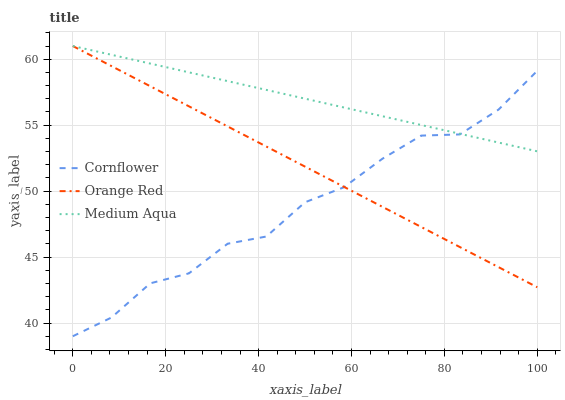Does Cornflower have the minimum area under the curve?
Answer yes or no. Yes. Does Medium Aqua have the maximum area under the curve?
Answer yes or no. Yes. Does Orange Red have the minimum area under the curve?
Answer yes or no. No. Does Orange Red have the maximum area under the curve?
Answer yes or no. No. Is Medium Aqua the smoothest?
Answer yes or no. Yes. Is Cornflower the roughest?
Answer yes or no. Yes. Is Orange Red the smoothest?
Answer yes or no. No. Is Orange Red the roughest?
Answer yes or no. No. Does Cornflower have the lowest value?
Answer yes or no. Yes. Does Orange Red have the lowest value?
Answer yes or no. No. Does Orange Red have the highest value?
Answer yes or no. Yes. Does Cornflower intersect Orange Red?
Answer yes or no. Yes. Is Cornflower less than Orange Red?
Answer yes or no. No. Is Cornflower greater than Orange Red?
Answer yes or no. No. 